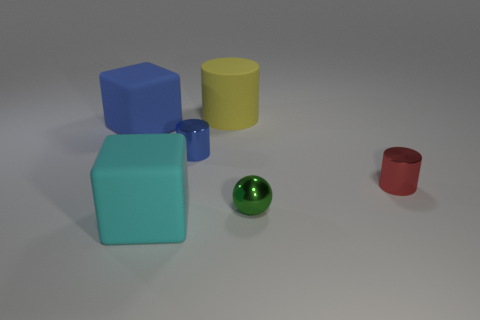What number of other large things have the same material as the big blue thing? There are two other objects in the image that appear to have the same glossy material as the large blue cube. These are the yellow cylinder and the red cup. 